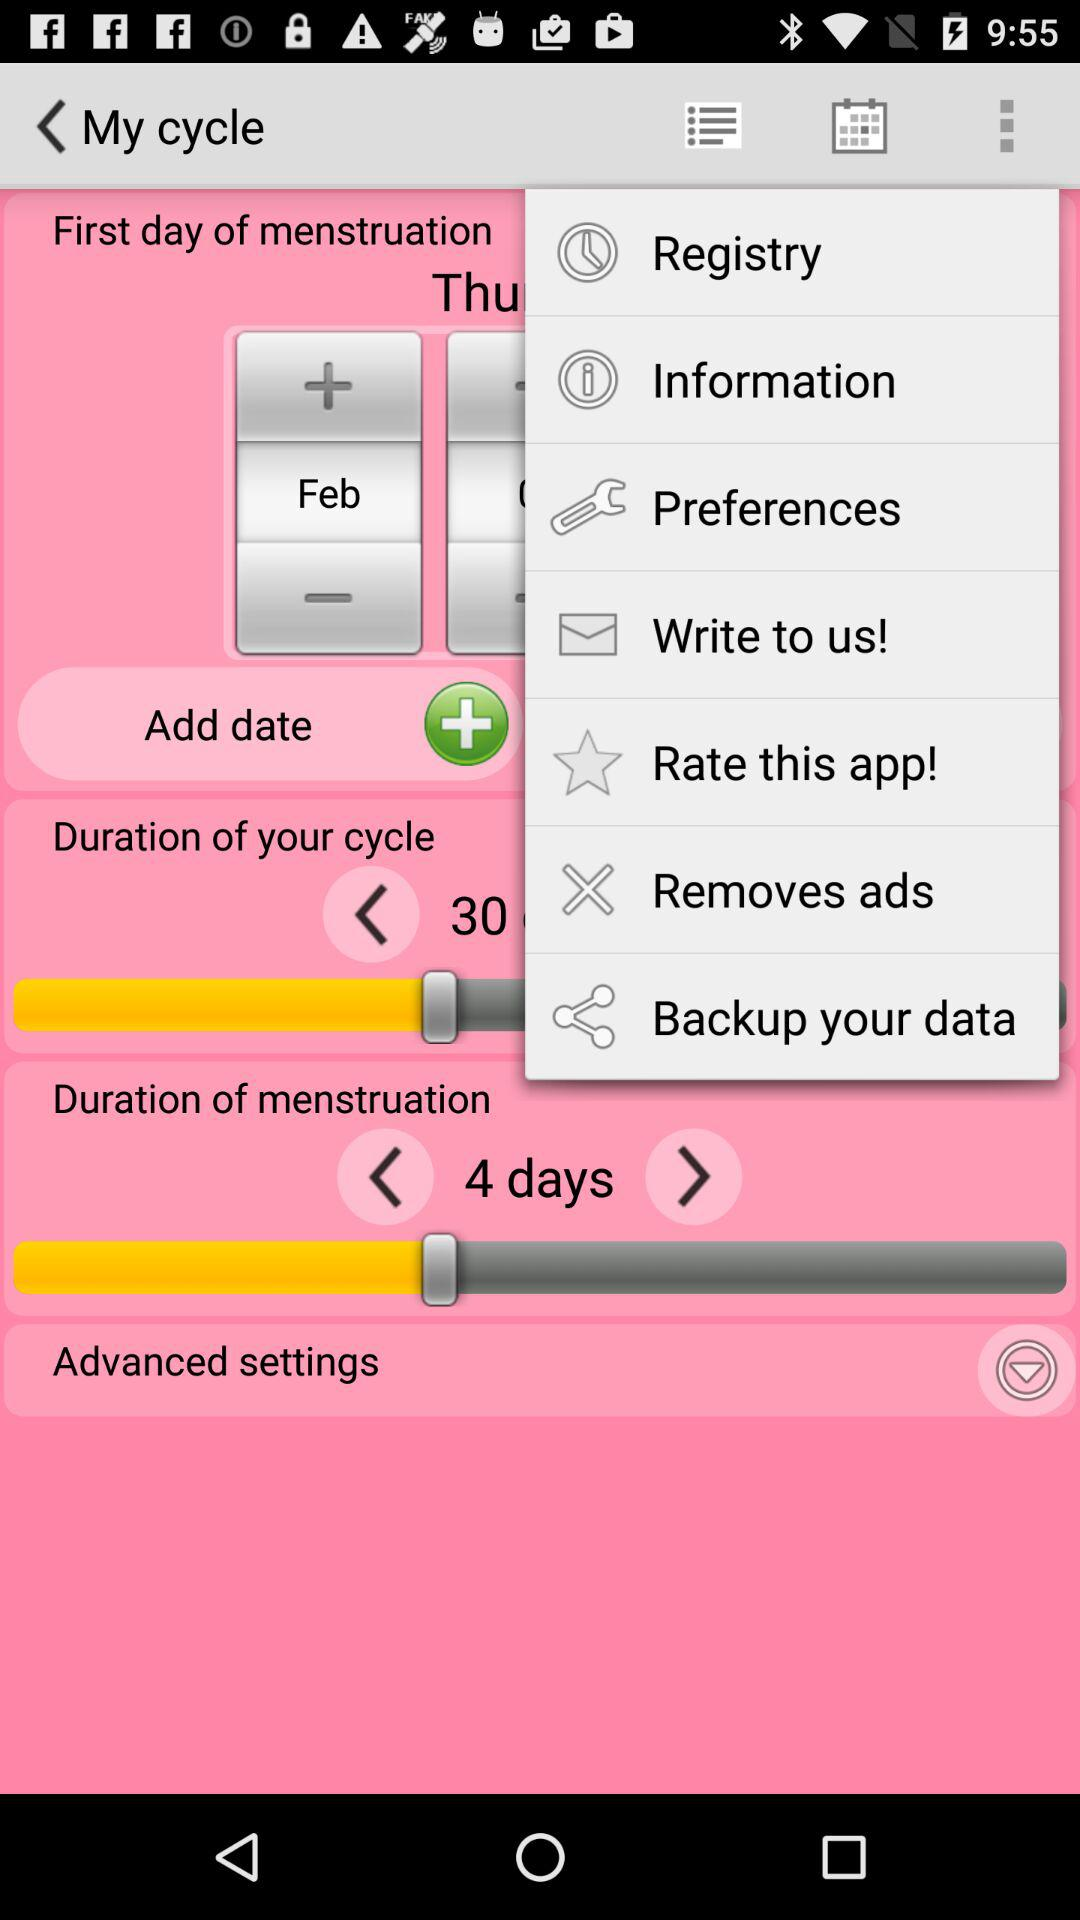What is the duration of menstruation? The duration of menstruation is 4 days. 